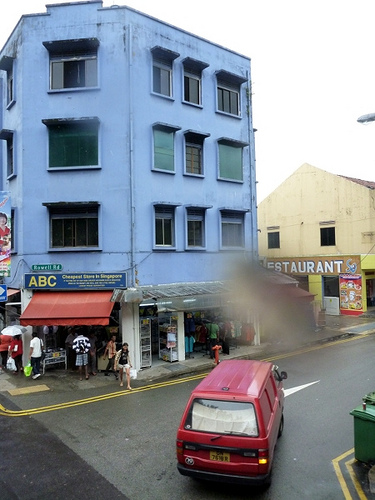<image>
Is there a water on the lens? Yes. Looking at the image, I can see the water is positioned on top of the lens, with the lens providing support. 